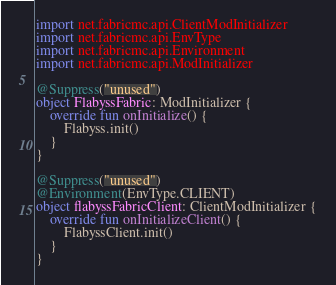<code> <loc_0><loc_0><loc_500><loc_500><_Kotlin_>import net.fabricmc.api.ClientModInitializer
import net.fabricmc.api.EnvType
import net.fabricmc.api.Environment
import net.fabricmc.api.ModInitializer

@Suppress("unused")
object FlabyssFabric: ModInitializer {
    override fun onInitialize() {
        Flabyss.init()
    }
}

@Suppress("unused")
@Environment(EnvType.CLIENT)
object flabyssFabricClient: ClientModInitializer {
    override fun onInitializeClient() {
        FlabyssClient.init()
    }
}</code> 